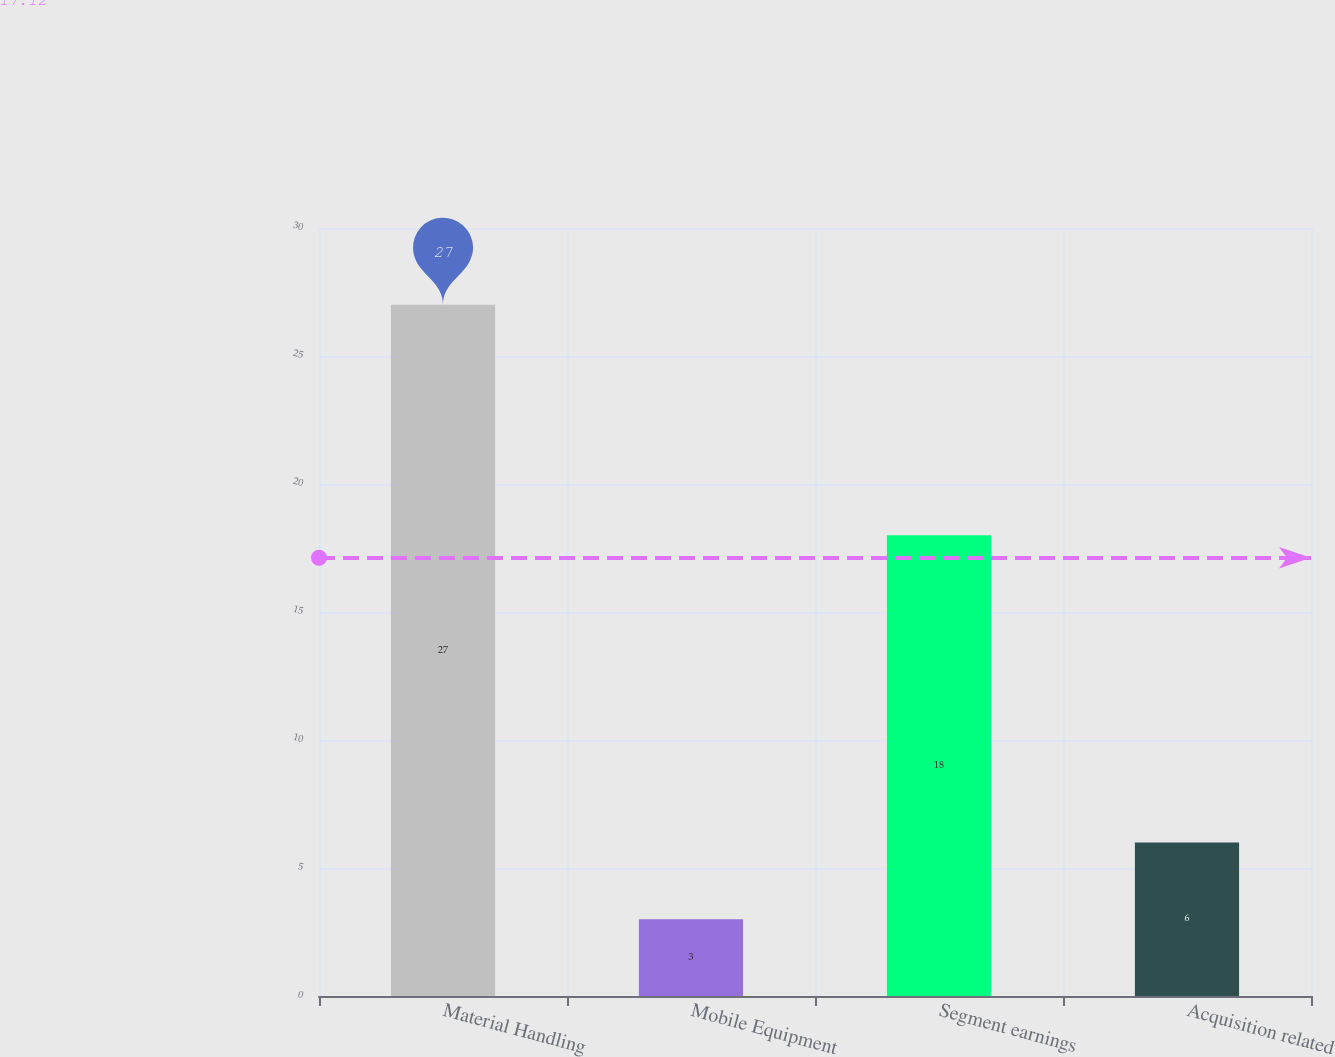<chart> <loc_0><loc_0><loc_500><loc_500><bar_chart><fcel>Material Handling<fcel>Mobile Equipment<fcel>Segment earnings<fcel>Acquisition related<nl><fcel>27<fcel>3<fcel>18<fcel>6<nl></chart> 